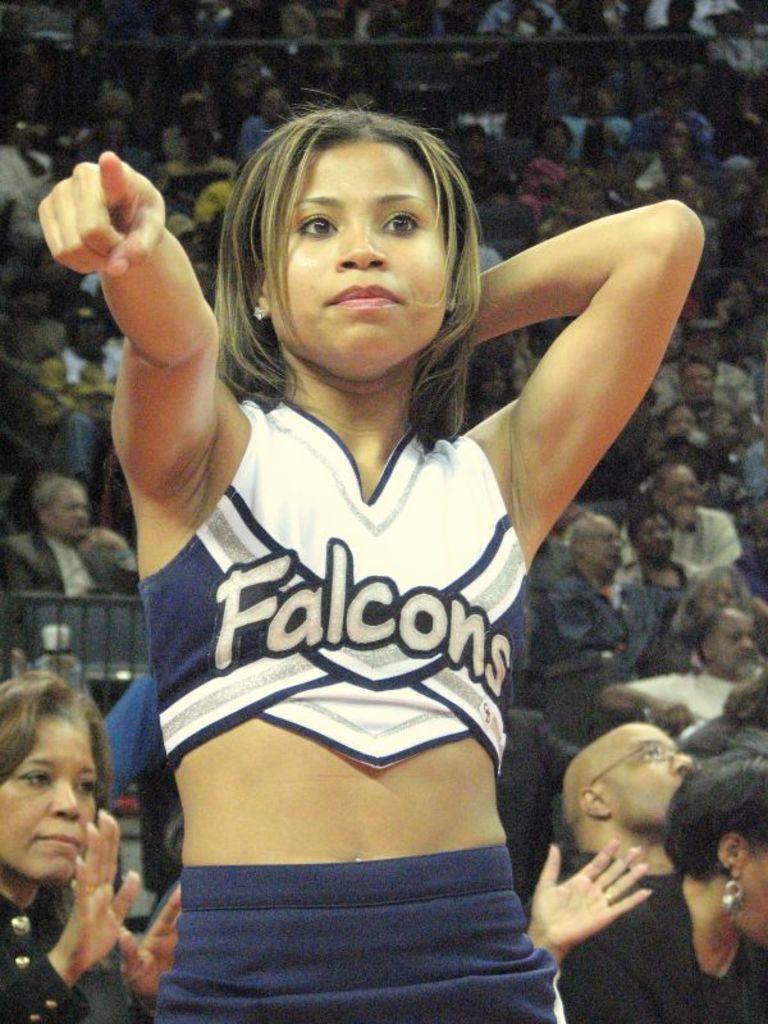What team is the cheerleader on?
Provide a succinct answer. Falcons. 